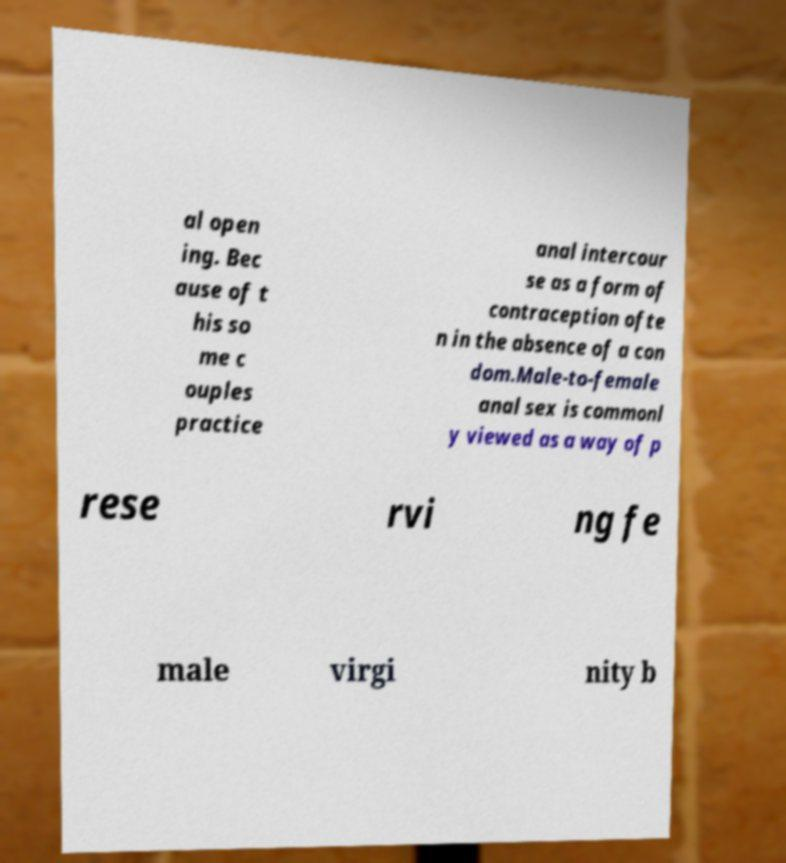Can you read and provide the text displayed in the image?This photo seems to have some interesting text. Can you extract and type it out for me? al open ing. Bec ause of t his so me c ouples practice anal intercour se as a form of contraception ofte n in the absence of a con dom.Male-to-female anal sex is commonl y viewed as a way of p rese rvi ng fe male virgi nity b 